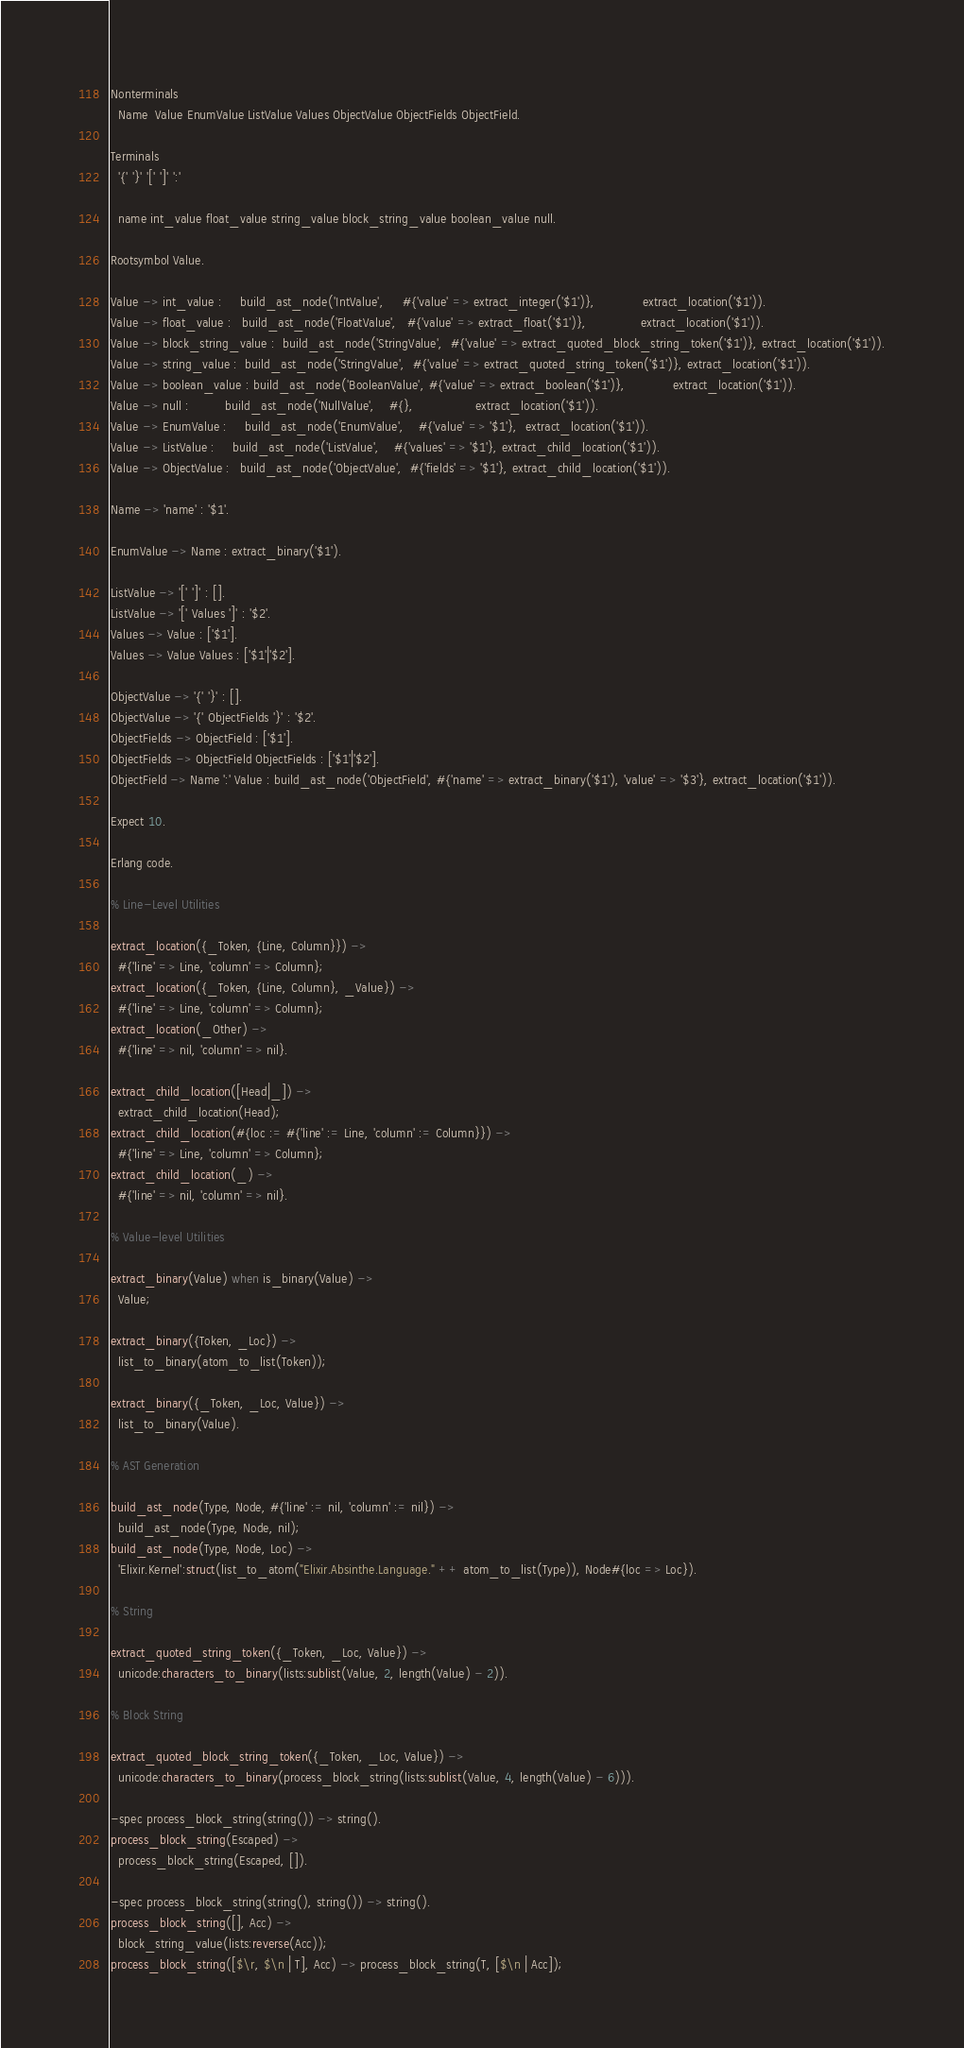Convert code to text. <code><loc_0><loc_0><loc_500><loc_500><_Erlang_>Nonterminals
  Name  Value EnumValue ListValue Values ObjectValue ObjectFields ObjectField.

Terminals
  '{' '}' '[' ']' ':' 

  name int_value float_value string_value block_string_value boolean_value null.

Rootsymbol Value.

Value -> int_value :     build_ast_node('IntValue',     #{'value' => extract_integer('$1')},             extract_location('$1')).
Value -> float_value :   build_ast_node('FloatValue',   #{'value' => extract_float('$1')},               extract_location('$1')).
Value -> block_string_value :  build_ast_node('StringValue',  #{'value' => extract_quoted_block_string_token('$1')}, extract_location('$1')).
Value -> string_value :  build_ast_node('StringValue',  #{'value' => extract_quoted_string_token('$1')}, extract_location('$1')).
Value -> boolean_value : build_ast_node('BooleanValue', #{'value' => extract_boolean('$1')},             extract_location('$1')).
Value -> null :          build_ast_node('NullValue',    #{},                 extract_location('$1')).
Value -> EnumValue :     build_ast_node('EnumValue',    #{'value' => '$1'},  extract_location('$1')).
Value -> ListValue :     build_ast_node('ListValue',    #{'values' => '$1'}, extract_child_location('$1')).
Value -> ObjectValue :   build_ast_node('ObjectValue',  #{'fields' => '$1'}, extract_child_location('$1')).

Name -> 'name' : '$1'.

EnumValue -> Name : extract_binary('$1').

ListValue -> '[' ']' : [].
ListValue -> '[' Values ']' : '$2'.
Values -> Value : ['$1'].
Values -> Value Values : ['$1'|'$2'].

ObjectValue -> '{' '}' : [].
ObjectValue -> '{' ObjectFields '}' : '$2'.
ObjectFields -> ObjectField : ['$1'].
ObjectFields -> ObjectField ObjectFields : ['$1'|'$2'].
ObjectField -> Name ':' Value : build_ast_node('ObjectField', #{'name' => extract_binary('$1'), 'value' => '$3'}, extract_location('$1')).

Expect 10.

Erlang code.

% Line-Level Utilities

extract_location({_Token, {Line, Column}}) ->
  #{'line' => Line, 'column' => Column};
extract_location({_Token, {Line, Column}, _Value}) ->
  #{'line' => Line, 'column' => Column};
extract_location(_Other) ->
  #{'line' => nil, 'column' => nil}.

extract_child_location([Head|_]) ->
  extract_child_location(Head);
extract_child_location(#{loc := #{'line' := Line, 'column' := Column}}) ->
  #{'line' => Line, 'column' => Column};
extract_child_location(_) ->
  #{'line' => nil, 'column' => nil}.

% Value-level Utilities

extract_binary(Value) when is_binary(Value) ->
  Value;

extract_binary({Token, _Loc}) ->
  list_to_binary(atom_to_list(Token));

extract_binary({_Token, _Loc, Value}) ->
  list_to_binary(Value).

% AST Generation

build_ast_node(Type, Node, #{'line' := nil, 'column' := nil}) ->
  build_ast_node(Type, Node, nil);
build_ast_node(Type, Node, Loc) ->
  'Elixir.Kernel':struct(list_to_atom("Elixir.Absinthe.Language." ++ atom_to_list(Type)), Node#{loc => Loc}).

% String

extract_quoted_string_token({_Token, _Loc, Value}) ->
  unicode:characters_to_binary(lists:sublist(Value, 2, length(Value) - 2)).

% Block String

extract_quoted_block_string_token({_Token, _Loc, Value}) ->
  unicode:characters_to_binary(process_block_string(lists:sublist(Value, 4, length(Value) - 6))).

-spec process_block_string(string()) -> string().
process_block_string(Escaped) ->
  process_block_string(Escaped, []).

-spec process_block_string(string(), string()) -> string().
process_block_string([], Acc) ->
  block_string_value(lists:reverse(Acc));
process_block_string([$\r, $\n | T], Acc) -> process_block_string(T, [$\n | Acc]);</code> 